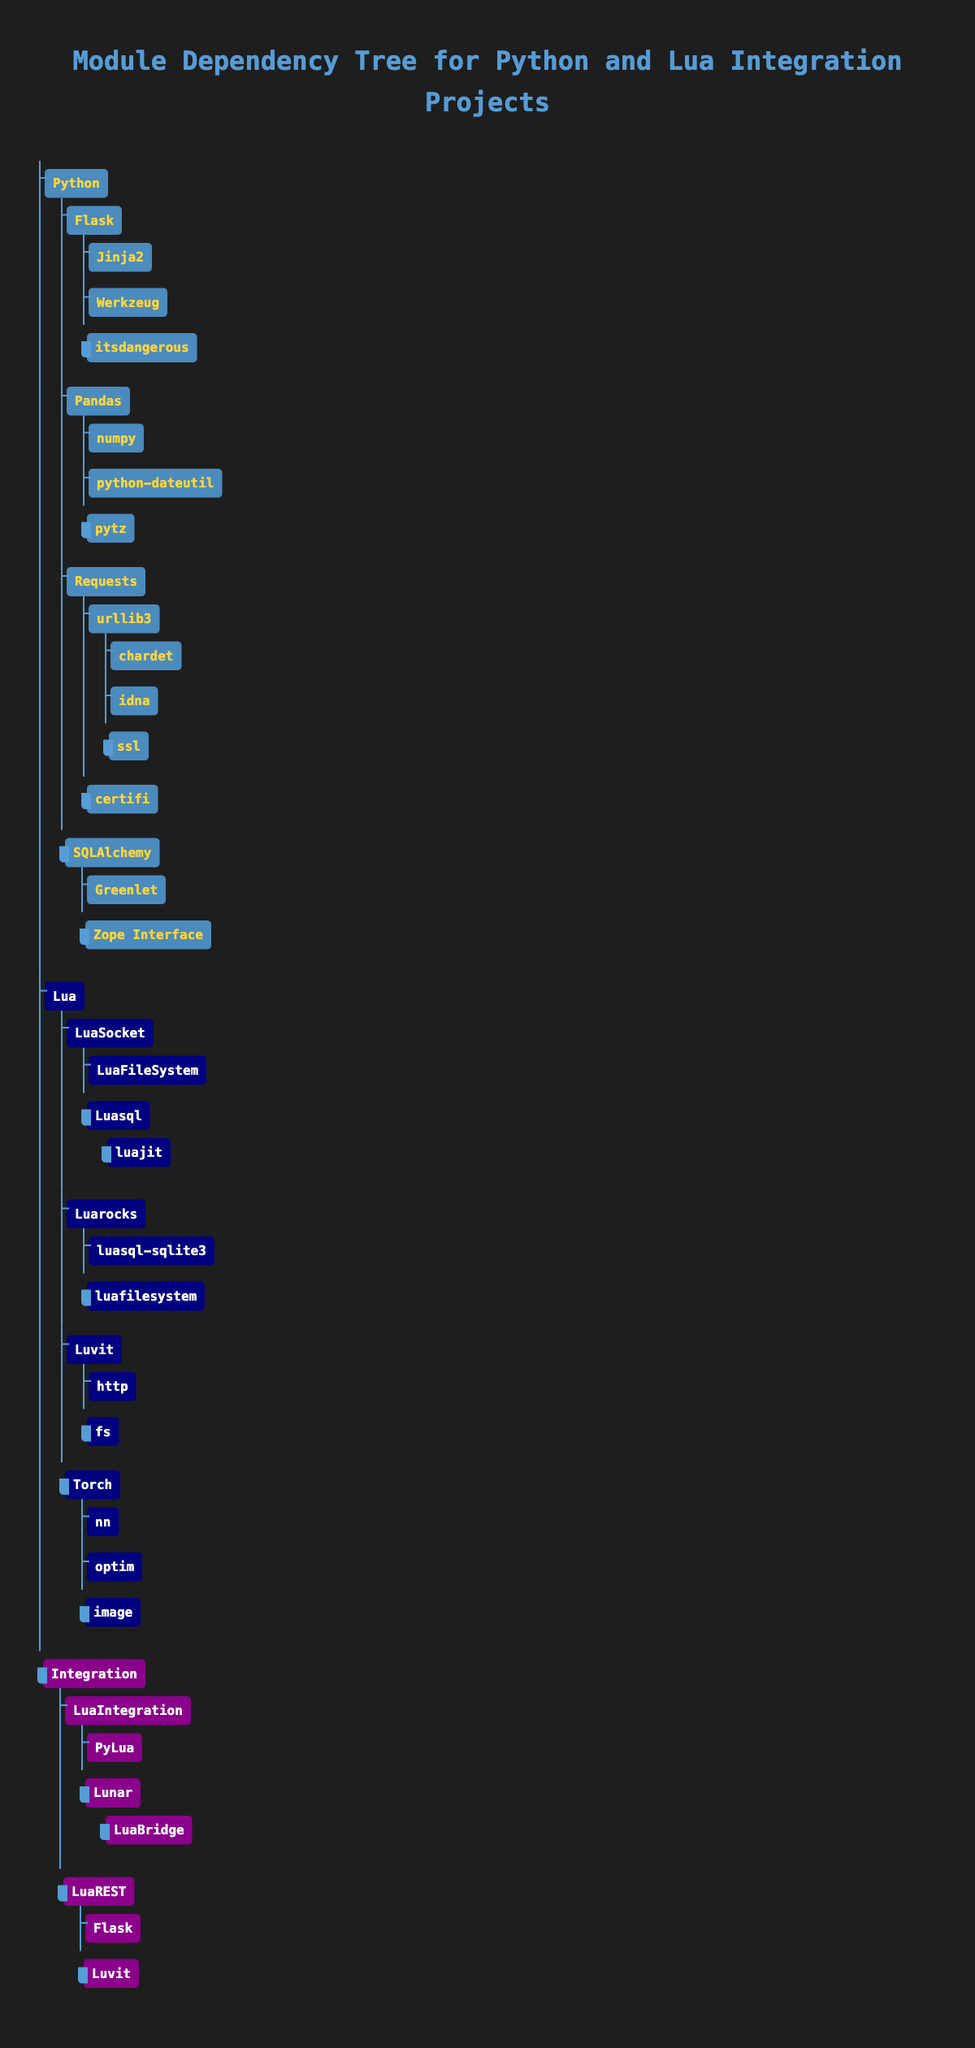What are the dependencies of Flask? In the table, under the "Python" category, we can see the entry for "Flask", which lists its dependencies directly beneath it. The dependencies listed include "Jinja2", "Werkzeug", and "itsdangerous".
Answer: Jinja2, Werkzeug, itsdangerous Does Requests have any dependencies? Checking the "Requests" module in the Python section shows that it indeed has dependencies, which are "urllib3" and "certifi". This indicates that the answer is true.
Answer: Yes How many dependencies does the Lua module LuaSocket have? By looking at "LuaSocket" in the Lua section, we see it has two dependencies listed: "LuaFileSystem" and "Luasql". Thus, we can count them and find that there are two dependencies total.
Answer: 2 What are the total number of dependencies listed for Python modules? To calculate this, we need to sum all the dependencies for each Python module found in the table: Flask (3), Pandas (3), Requests (4), and SQLAlchemy (2). Adding these gives us 3 + 3 + 4 + 2 = 12.
Answer: 12 Is Luvit a dependency of LuaREST? Looking under the "Integration" section, we can locate the "LuaREST" module. It lists "Flask" and "Luvit" as its dependencies, confirming that Luvit is indeed a dependency.
Answer: Yes Which module has the highest number of dependencies in the Python section? Checking the dependencies: Flask (3), Pandas (3), Requests (4), and SQLAlchemy (2), we find that "Requests" has the highest number with 4 dependencies.
Answer: Requests Which Lua module has a dependency on luajit? Looking at the Lua section and specifically the "Luasql", we find it has one dependency, which is "luajit". Hence, "Luasql" is the only module that has a dependency on "luajit".
Answer: Luasql Are all dependencies of LuaIntegration also listed in the Integration section? In "LuaIntegration", the dependencies are "PyLua" and "Lunar". The module "Lunar" has "LuaBridge" listed, but both "PyLua" and "LuaBridge" are under Integration. As all dependencies correspond to entries under Integration, we can conclude that yes, all are listed.
Answer: Yes How many total dependencies does the Integration category contain? Analyzing the Integration category: LuaIntegration (2), with "PyLua" and "Lunar" (which has 1 sub-dependency), and LuaREST (2). Therefore, the total count is 2 + 1 (from Lunar) + 2 = 5 dependencies overall.
Answer: 5 What is the only dependency of Torch? Under the "Torch" module in the Lua category, we find its dependencies listed as "nn", "optim", and "image". These are straightforward. Therefore, there isn’t an "only" dependency, but multiple.
Answer: nn, optim, image 